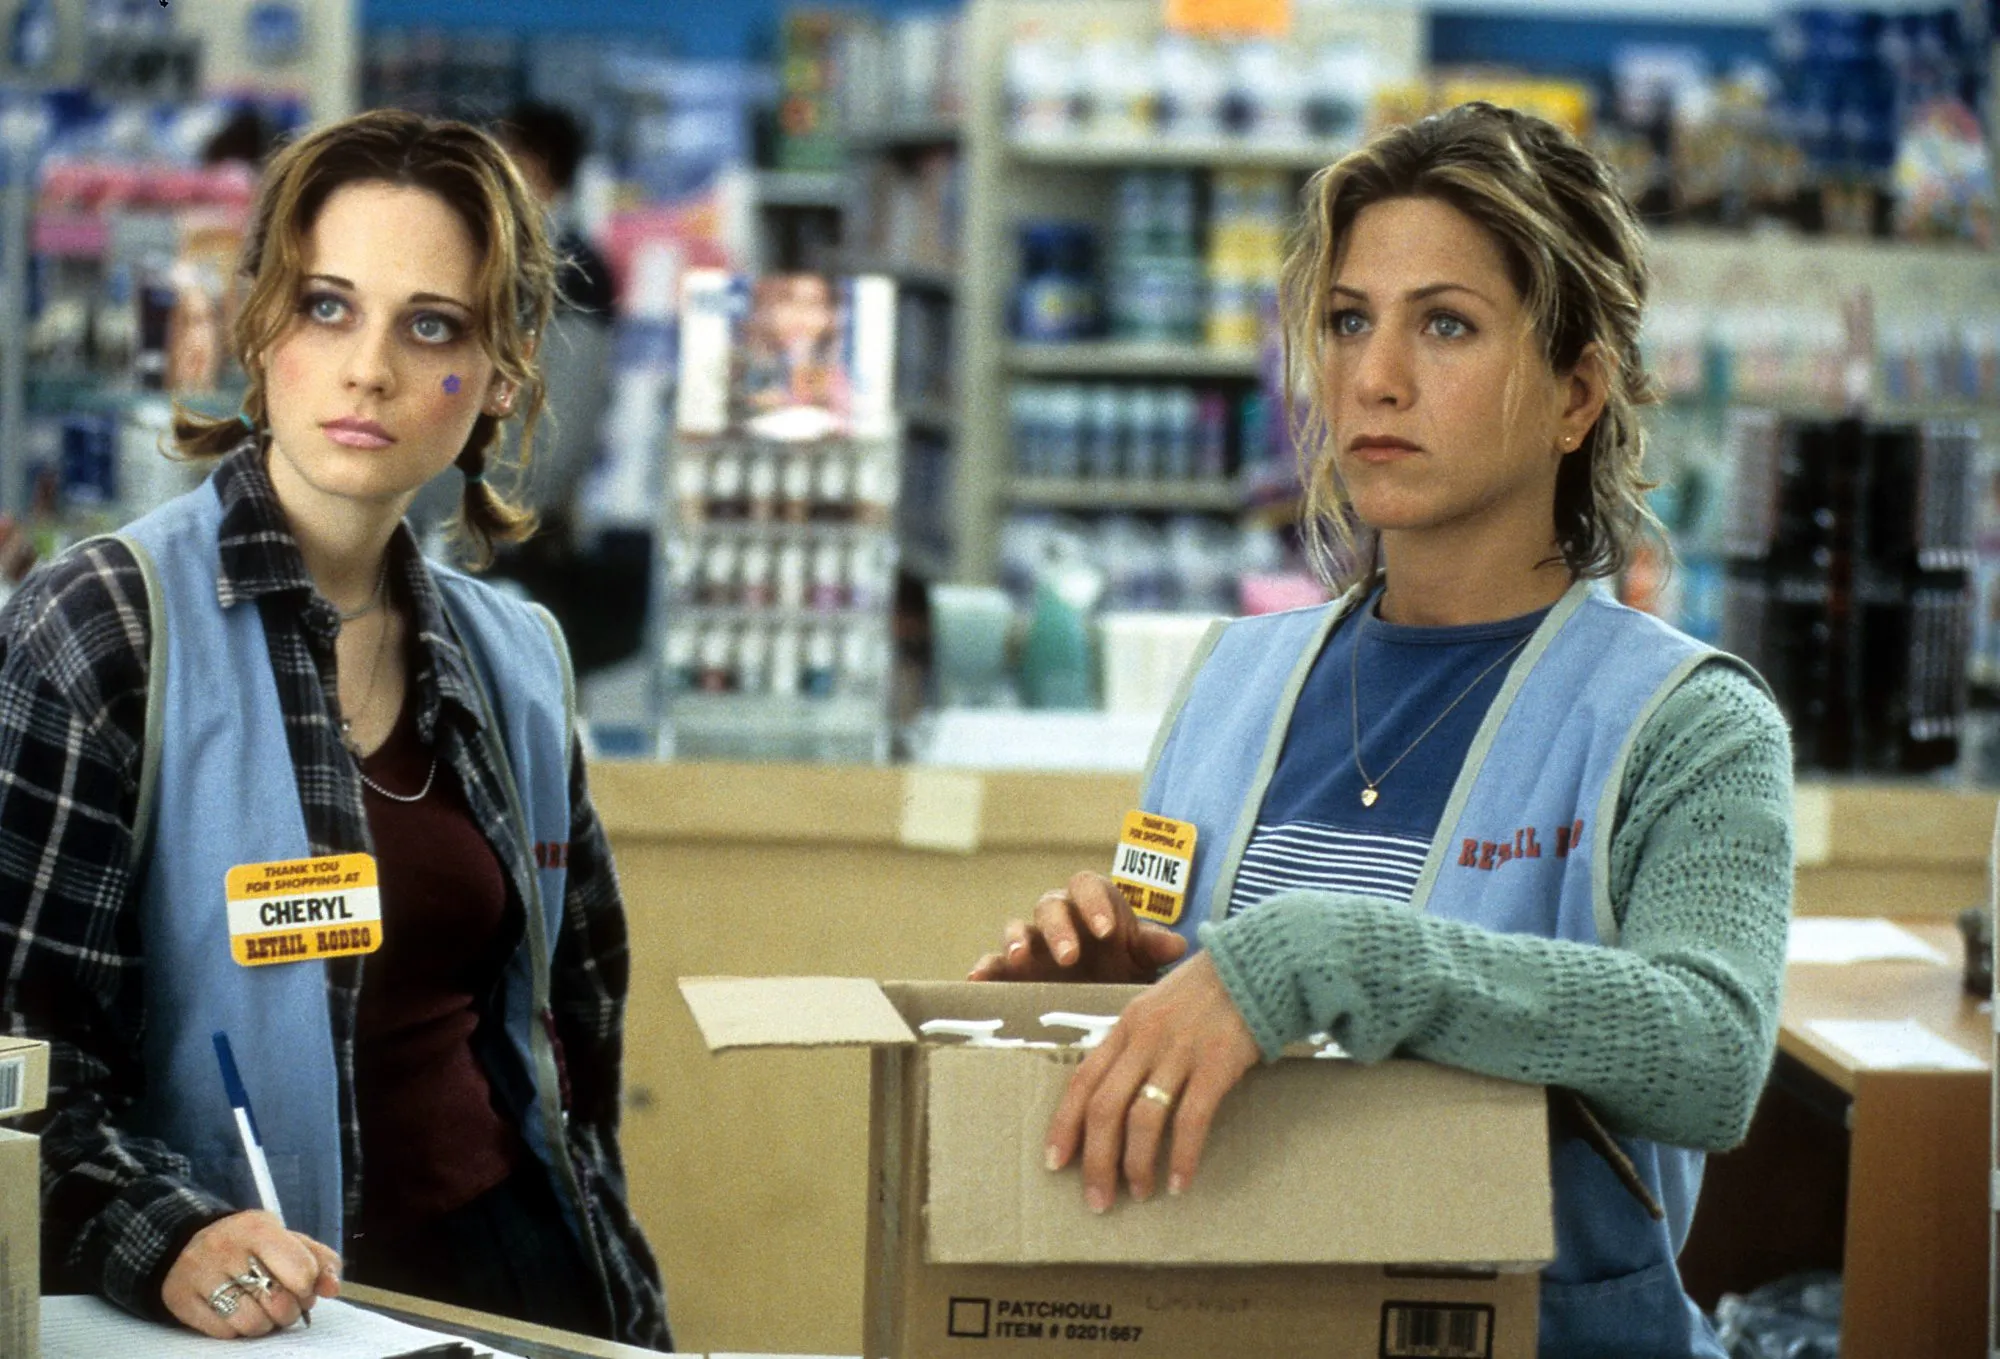What might be the daily routines of Cheryl and Justine in that store? Cheryl and Justine likely start their day by clocking in and attending a brief team meeting to go over their tasks and any store updates. Cheryl, being more experienced, might handle customer service and address any complaints or issues that arise. She also stocks shelves and helps with inventory, ensuring products are arranged neatly and priced correctly. Justine, who seems meticulous, might be in charge of restocking items and organizing the backroom. She could also assist in training new employees, helping them understand store policies and procedures. Both characters work together to keep the store running efficiently, taking breaks in between to grab a quick snack or touch base about progress. Create a very long and detailed backstory for Justine. Justine had always been a pillar of resilience and determination. Born and raised in a small town with tight-knit community values, she spent her childhood helping out at her family’s modest convenience store. This early exposure to retail work instilled in her an inherent sense of responsibility and a strong work ethic. After graduating high school, Justine moved to the city with dreams of pursuing higher education and eventually opening her own boutique store. However, financial constraints and life’s unpredictability made her shelve these dreams temporarily. She took up various jobs to support herself, ranging from waitressing to retail clerk positions. Each job added a layer of experience and understanding of the customer service landscape. Eventually, she landed a job at the store where the picture is set. Her inherent knack for organization and compassionate approach to customer service did not go unnoticed by her supervisors. Her colleagues quickly grew fond of her, appreciating her ability to remain calm under pressure and her willingness to assist them in their tasks. Beyond this professional facade, Justine had a rich personal life filled with experiences that shaped her tenacious yet empathetic outlook. She once volunteered at a local shelter, where she realized the transformative power of kindness and community support. In her free time, she relished exploring nature trails, finding solace in the tranquillity of the woods and the rhythmic rustling of leaves. She also harbored a passion for cooking, often experimenting with recipes that reminded her of her mother’s comforting meals. These hobbies provided a necessary reprieve from her often hectic work life. Over the years, Justine's journey at the store saw her evolve from a reserved newcomer to a respected team leader. Despite numerous challenges, her perseverance and optimism remained unwavering, driving her commitment to her job and her aspiration to someday achieve her entrepreneurial dreams. 